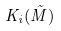Convert formula to latex. <formula><loc_0><loc_0><loc_500><loc_500>K _ { i } ( \tilde { M } )</formula> 